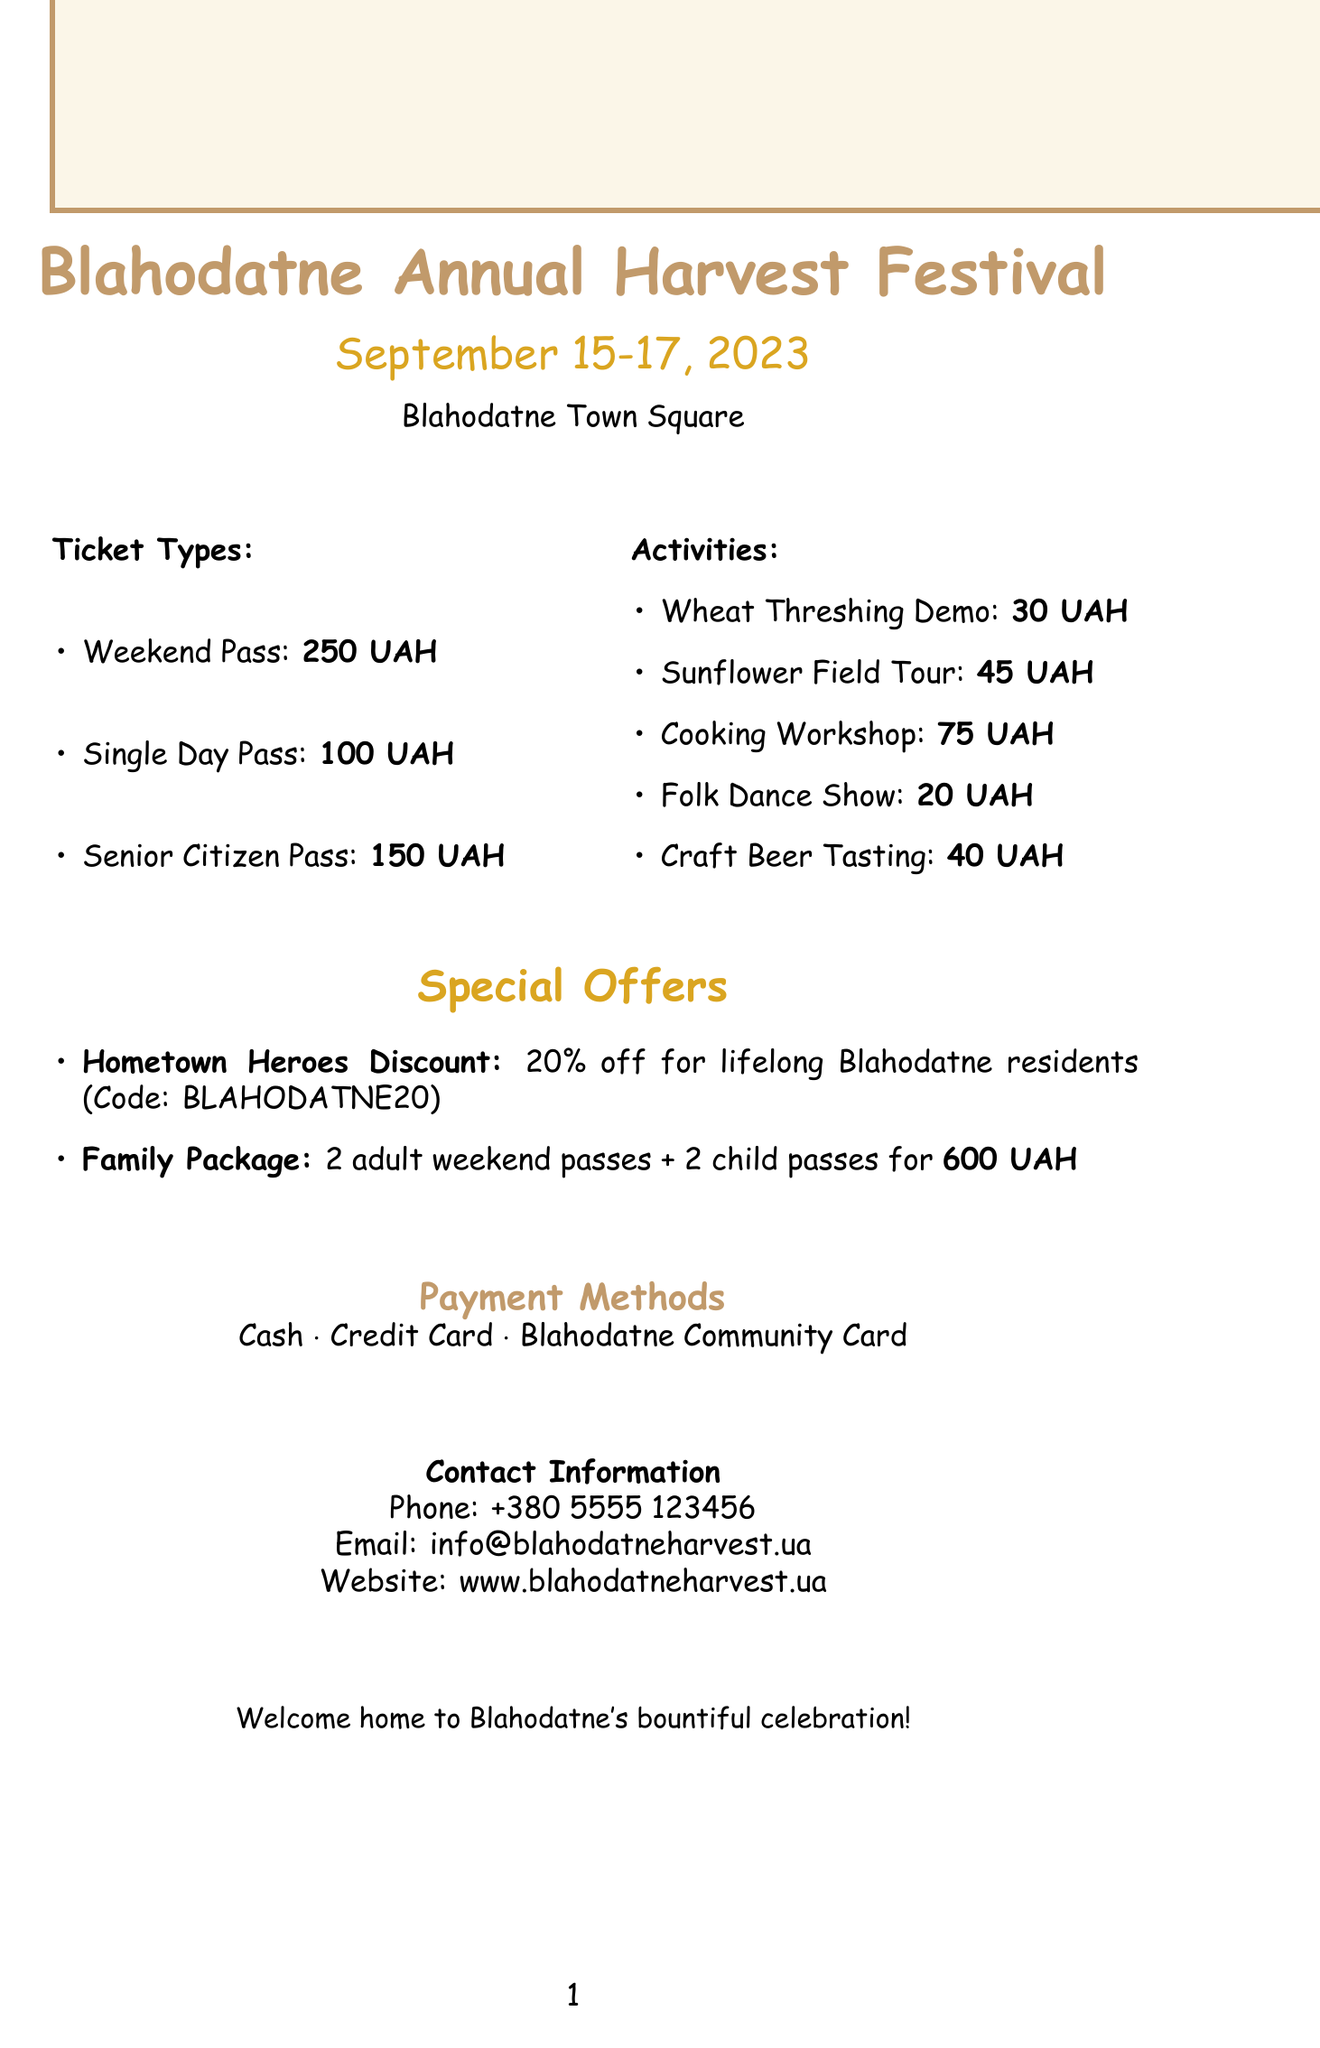what is the festival's name? The festival's name is stated at the beginning of the document.
Answer: Blahodatne Annual Harvest Festival when is the festival taking place? The dates for the festival are mentioned prominently in the document.
Answer: September 15-17, 2023 where is the festival located? The location of the festival is specified in the introduction of the document.
Answer: Blahodatne Town Square how much is a Weekend Pass? The price for a Weekend Pass is included in the ticket types section of the document.
Answer: 250 UAH what is the price of the Family Package? The Family Package price is listed under special offers in the document.
Answer: 600 UAH what discount do Blahodatne residents receive? The discount offered to lifelong residents is detailed in the special offers section.
Answer: 20% off how long is the Local Cuisine Cooking Workshop? The duration of the Local Cuisine Cooking Workshop is provided in the activities section.
Answer: 3 hours which payment methods are accepted? The accepted payment methods are listed in the payment methods section of the document.
Answer: Cash, Credit Card, Blahodatne Community Card what is included in the Family Package? The details of the Family Package are mentioned under special offers in the document.
Answer: 2 adult weekend passes + 2 child passes 